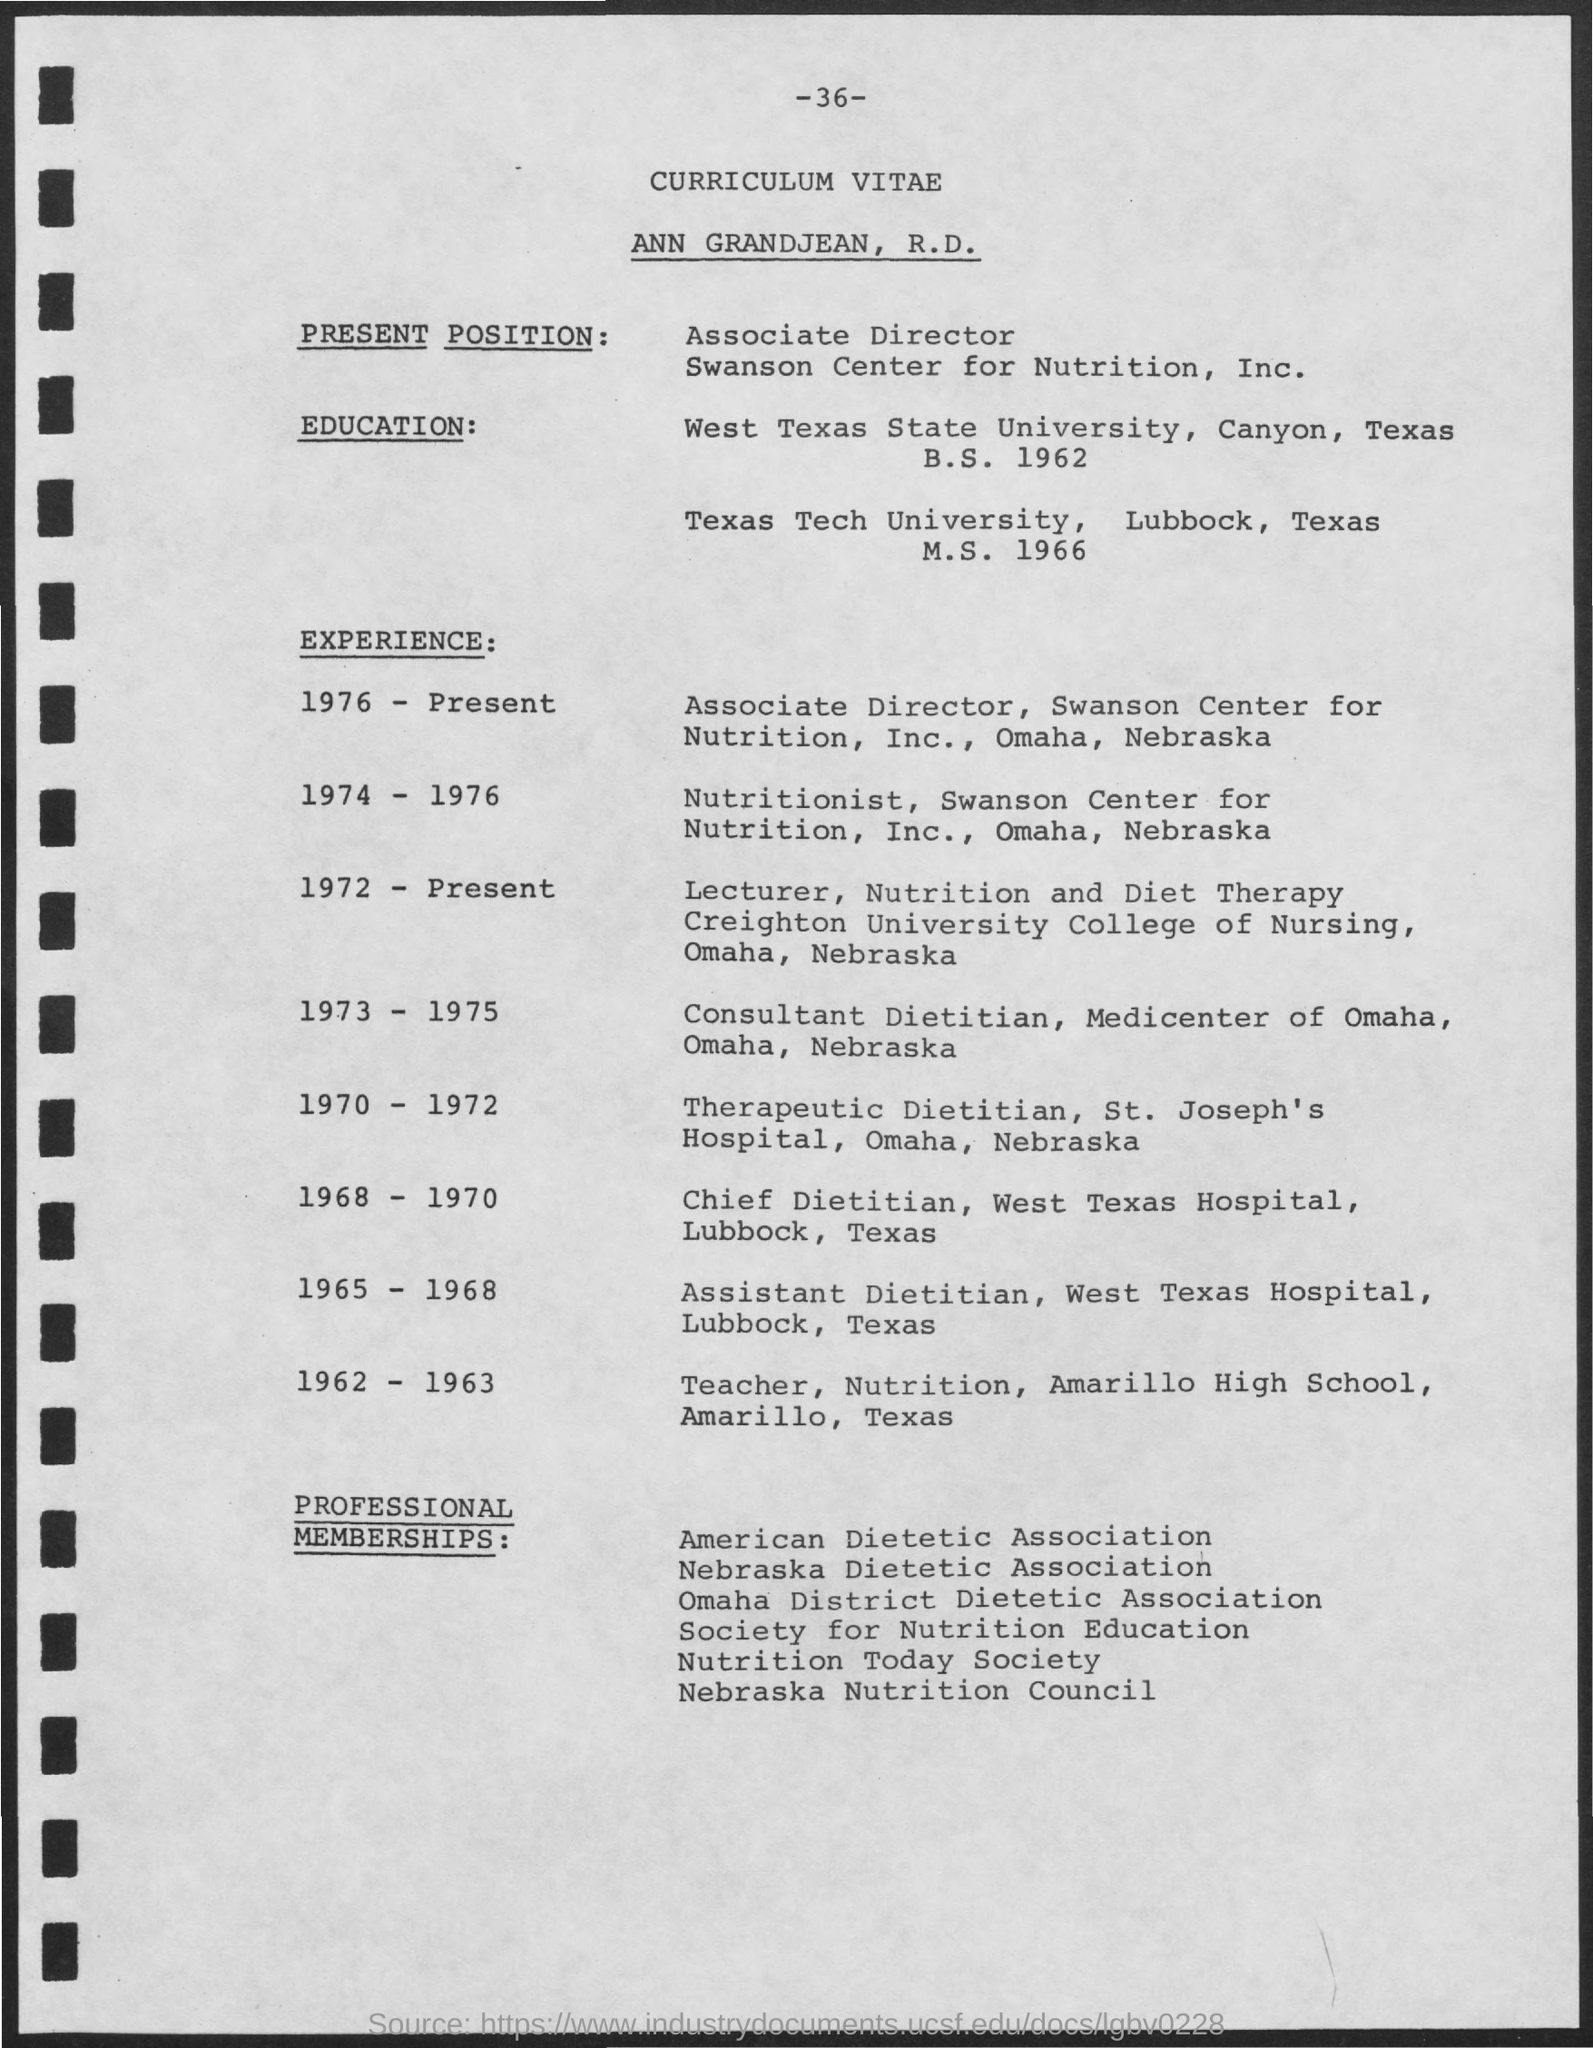Who's curriculum vitae is given here?
Your response must be concise. ANN GRANDJEAN, R.D. What is the page no mentioned in this document?
Offer a terse response. -36-. What is the present position of ANN GRANDJEAN, R.D.?
Keep it short and to the point. Associate Director, Swanson Center for Nutrition, Inc. When did ANN GRANDJEAN, R.D. completed her B.S. degree?
Your answer should be compact. 1962. During which year, ANN GRANDJEAN, R.D. has worked as a consultant Dietitian in the Medicenter of Omaha?
Make the answer very short. 1973 - 1975. What was the job title of ANN GRANDJEAN, R.D. during the year 1965 - 1968?
Make the answer very short. Assistant Dietitian, West Texas Hospital. 